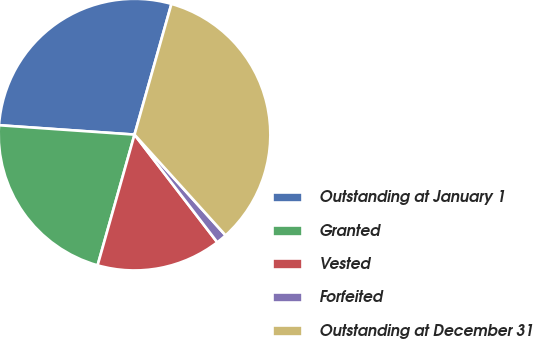Convert chart. <chart><loc_0><loc_0><loc_500><loc_500><pie_chart><fcel>Outstanding at January 1<fcel>Granted<fcel>Vested<fcel>Forfeited<fcel>Outstanding at December 31<nl><fcel>28.28%<fcel>21.72%<fcel>14.81%<fcel>1.27%<fcel>33.92%<nl></chart> 